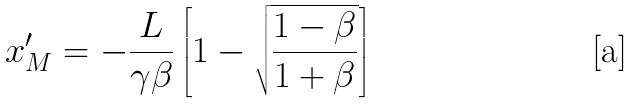<formula> <loc_0><loc_0><loc_500><loc_500>x ^ { \prime } _ { M } = - \frac { L } { \gamma \beta } \left [ 1 - \sqrt { \frac { 1 - \beta } { 1 + \beta } } \right ]</formula> 